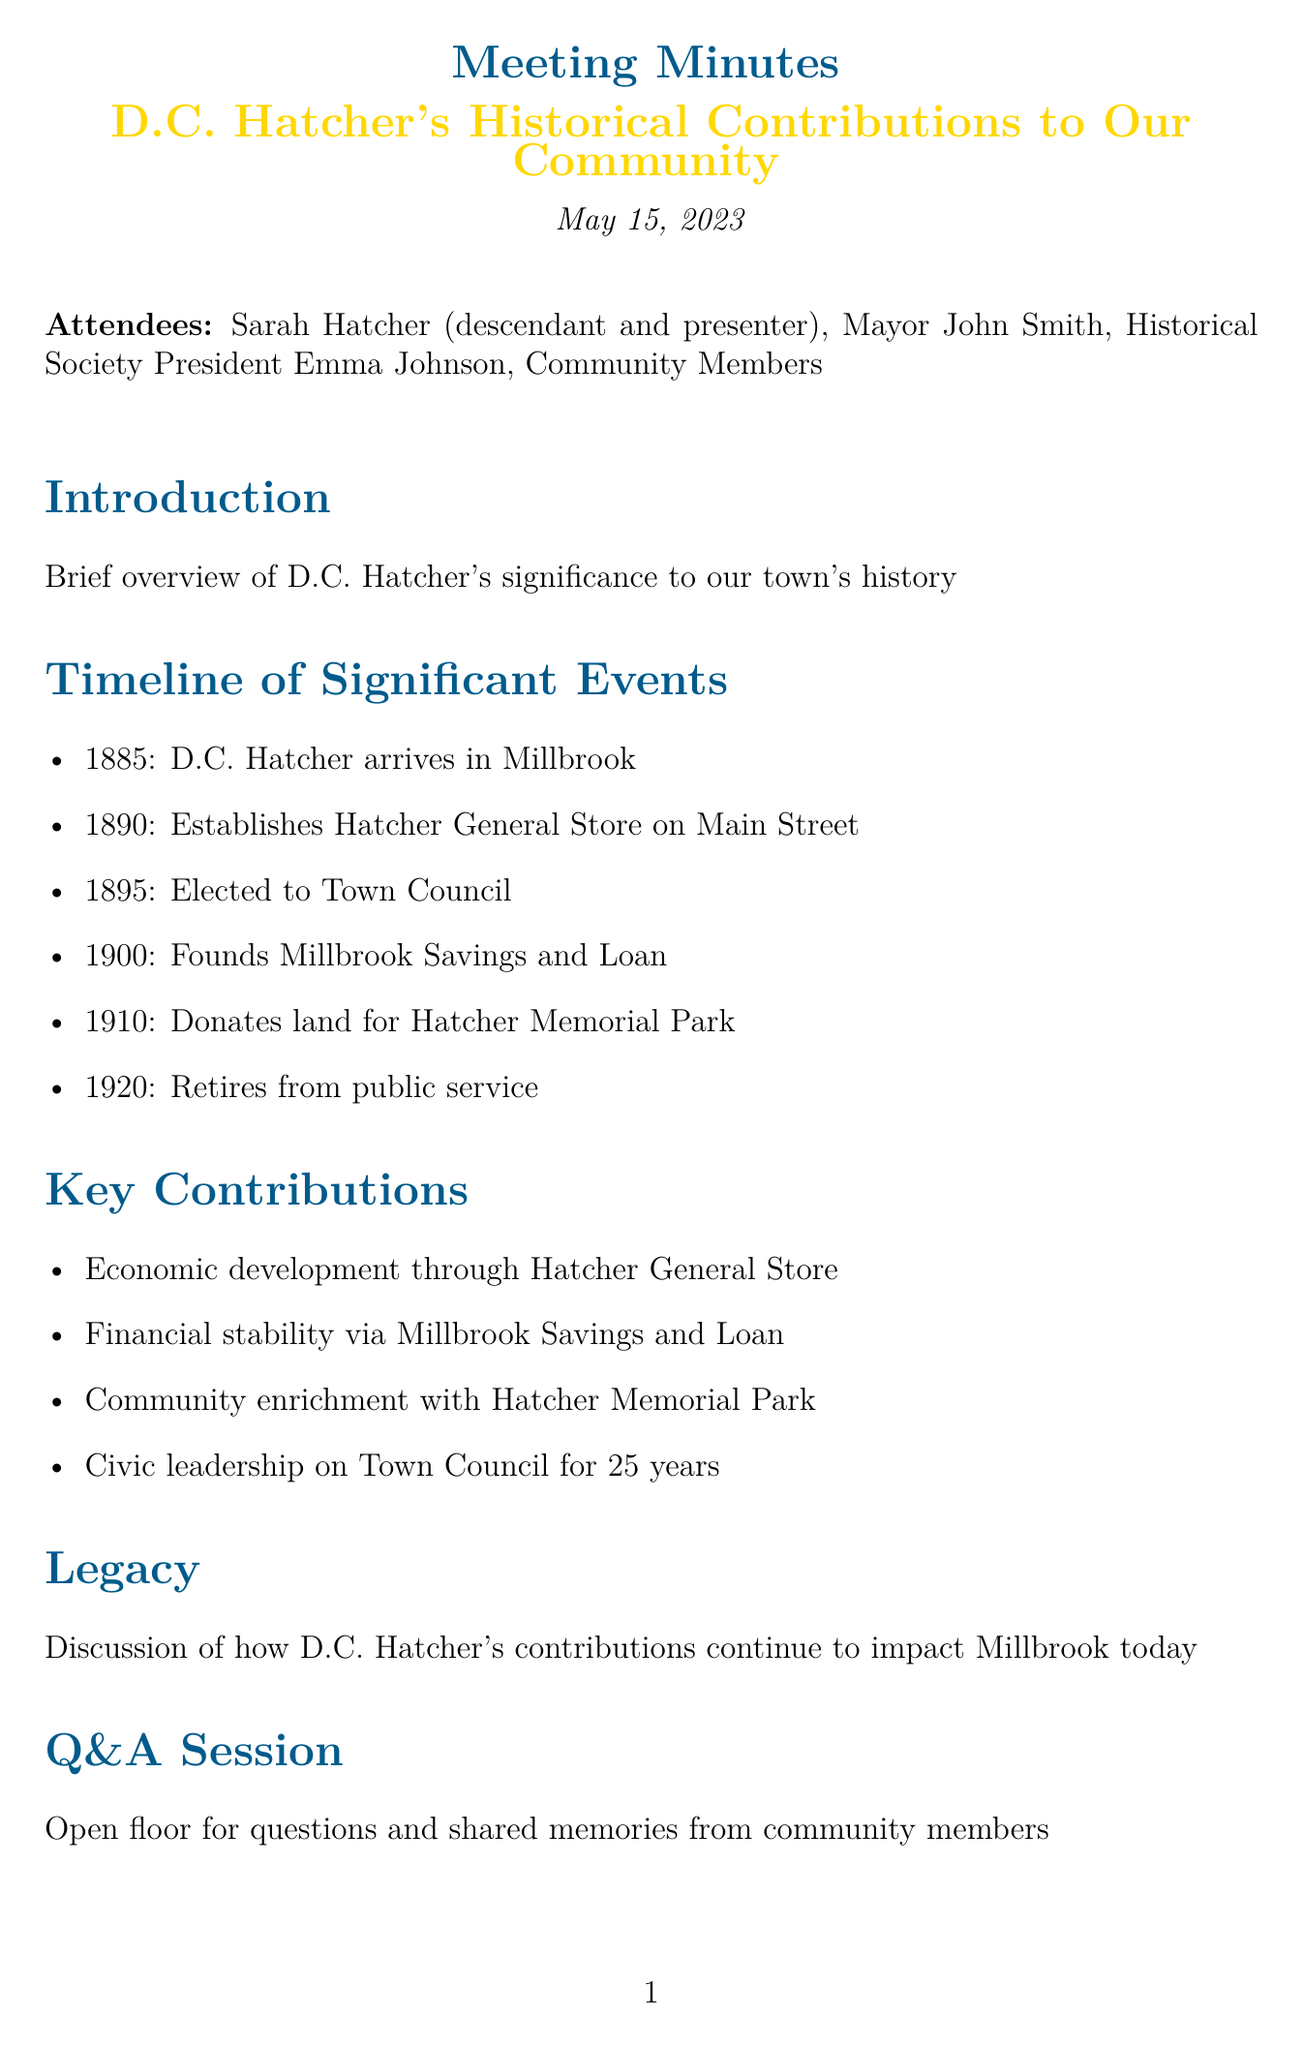What year did D.C. Hatcher arrive in Millbrook? The document lists the year D.C. Hatcher arrived in Millbrook as 1885 under the timeline of significant events.
Answer: 1885 What significant establishment did D.C. Hatcher create in 1890? The timeline indicates that he established Hatcher General Store on Main Street in 1890.
Answer: Hatcher General Store How many years did D.C. Hatcher serve on the Town Council? The document mentions that D.C. Hatcher served on the Town Council for 25 years, which is highlighted in the key contributions section.
Answer: 25 years In which year did D.C. Hatcher donate land for a park? Referring to the timeline, D.C. Hatcher donated land for Hatcher Memorial Park in 1910.
Answer: 1910 What is one of D.C. Hatcher's key contributions mentioned in the document? The document lists several key contributions, including the economic development through Hatcher General Store.
Answer: Economic development through Hatcher General Store Who presented during the meeting? The attendees section identifies Sarah Hatcher as the presenter during the meeting.
Answer: Sarah Hatcher What is the purpose of the Q&A session mentioned in the document? The document states that the Q&A session is an open floor for questions and shared memories from community members.
Answer: Open floor for questions and shared memories What is highlighted as important in the closing remarks? The closing remarks emphasize the importance of preserving local history and honoring community leaders, as stated in the document.
Answer: Preserving local history and honoring community leaders 